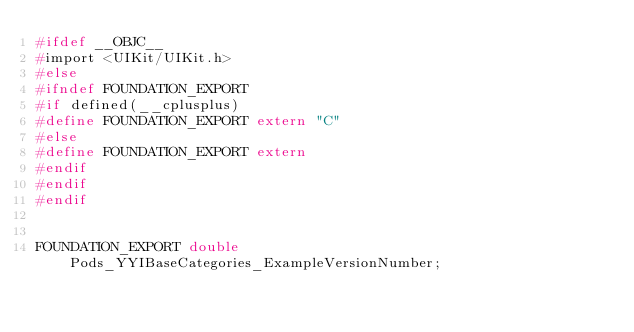Convert code to text. <code><loc_0><loc_0><loc_500><loc_500><_C_>#ifdef __OBJC__
#import <UIKit/UIKit.h>
#else
#ifndef FOUNDATION_EXPORT
#if defined(__cplusplus)
#define FOUNDATION_EXPORT extern "C"
#else
#define FOUNDATION_EXPORT extern
#endif
#endif
#endif


FOUNDATION_EXPORT double Pods_YYIBaseCategories_ExampleVersionNumber;</code> 